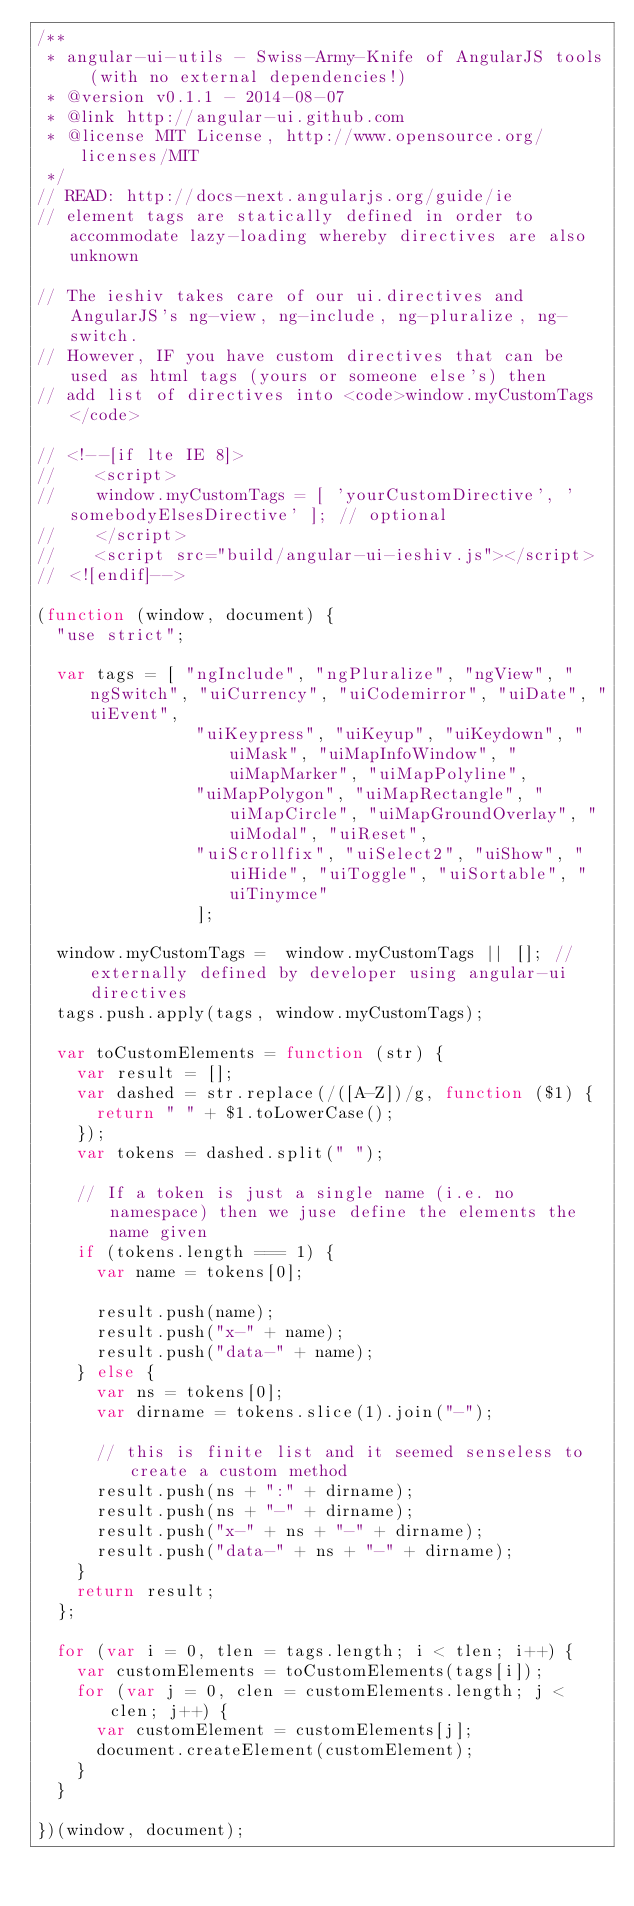<code> <loc_0><loc_0><loc_500><loc_500><_JavaScript_>/**
 * angular-ui-utils - Swiss-Army-Knife of AngularJS tools (with no external dependencies!)
 * @version v0.1.1 - 2014-08-07
 * @link http://angular-ui.github.com
 * @license MIT License, http://www.opensource.org/licenses/MIT
 */
// READ: http://docs-next.angularjs.org/guide/ie
// element tags are statically defined in order to accommodate lazy-loading whereby directives are also unknown

// The ieshiv takes care of our ui.directives and AngularJS's ng-view, ng-include, ng-pluralize, ng-switch.
// However, IF you have custom directives that can be used as html tags (yours or someone else's) then
// add list of directives into <code>window.myCustomTags</code>

// <!--[if lte IE 8]>
//    <script>
//    window.myCustomTags = [ 'yourCustomDirective', 'somebodyElsesDirective' ]; // optional
//    </script>
//    <script src="build/angular-ui-ieshiv.js"></script>
// <![endif]-->

(function (window, document) {
  "use strict";

  var tags = [ "ngInclude", "ngPluralize", "ngView", "ngSwitch", "uiCurrency", "uiCodemirror", "uiDate", "uiEvent",
                "uiKeypress", "uiKeyup", "uiKeydown", "uiMask", "uiMapInfoWindow", "uiMapMarker", "uiMapPolyline",
                "uiMapPolygon", "uiMapRectangle", "uiMapCircle", "uiMapGroundOverlay", "uiModal", "uiReset",
                "uiScrollfix", "uiSelect2", "uiShow", "uiHide", "uiToggle", "uiSortable", "uiTinymce"
                ];

  window.myCustomTags =  window.myCustomTags || []; // externally defined by developer using angular-ui directives
  tags.push.apply(tags, window.myCustomTags);

  var toCustomElements = function (str) {
    var result = [];
    var dashed = str.replace(/([A-Z])/g, function ($1) {
      return " " + $1.toLowerCase();
    });
    var tokens = dashed.split(" ");

    // If a token is just a single name (i.e. no namespace) then we juse define the elements the name given
    if (tokens.length === 1) {
      var name = tokens[0];

      result.push(name);
      result.push("x-" + name);
      result.push("data-" + name);
    } else {
      var ns = tokens[0];
      var dirname = tokens.slice(1).join("-");

      // this is finite list and it seemed senseless to create a custom method
      result.push(ns + ":" + dirname);
      result.push(ns + "-" + dirname);
      result.push("x-" + ns + "-" + dirname);
      result.push("data-" + ns + "-" + dirname);
    }
    return result;
  };

  for (var i = 0, tlen = tags.length; i < tlen; i++) {
    var customElements = toCustomElements(tags[i]);
    for (var j = 0, clen = customElements.length; j < clen; j++) {
      var customElement = customElements[j];
      document.createElement(customElement);
    }
  }

})(window, document);
</code> 